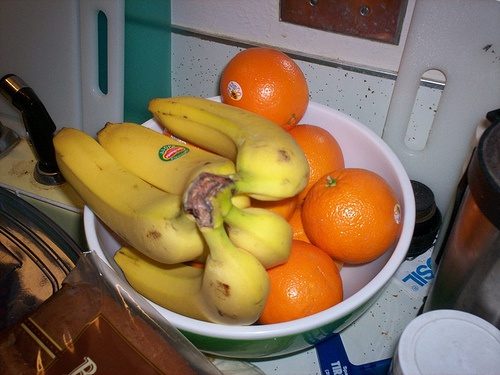Describe the objects in this image and their specific colors. I can see bowl in black, red, olive, and orange tones, banana in black, olive, orange, and khaki tones, banana in black, olive, khaki, and tan tones, orange in black, red, orange, and brown tones, and orange in black, red, and brown tones in this image. 